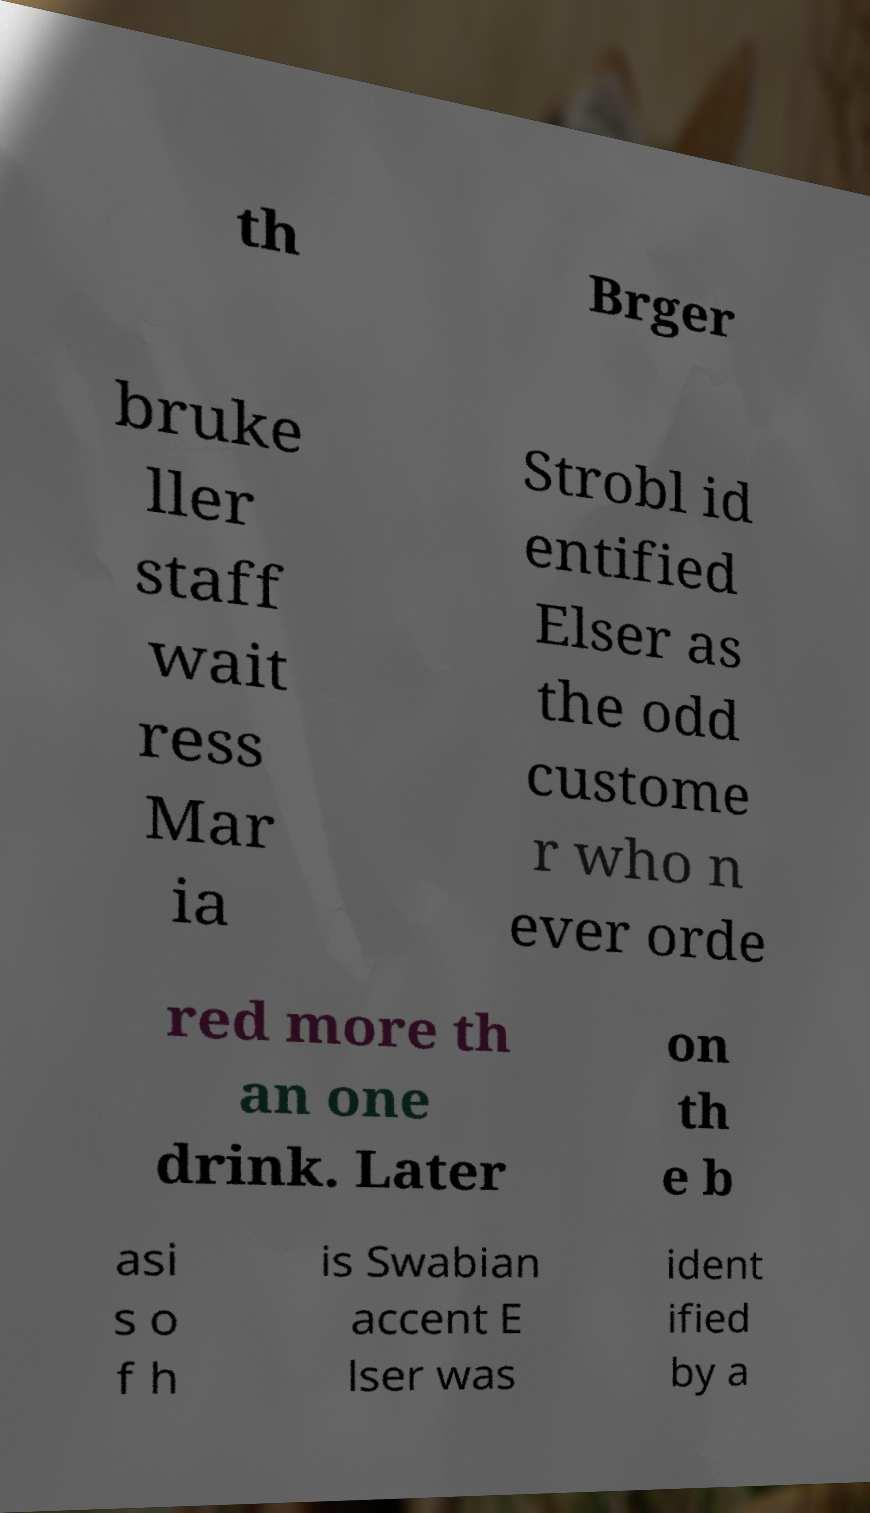Please identify and transcribe the text found in this image. th Brger bruke ller staff wait ress Mar ia Strobl id entified Elser as the odd custome r who n ever orde red more th an one drink. Later on th e b asi s o f h is Swabian accent E lser was ident ified by a 